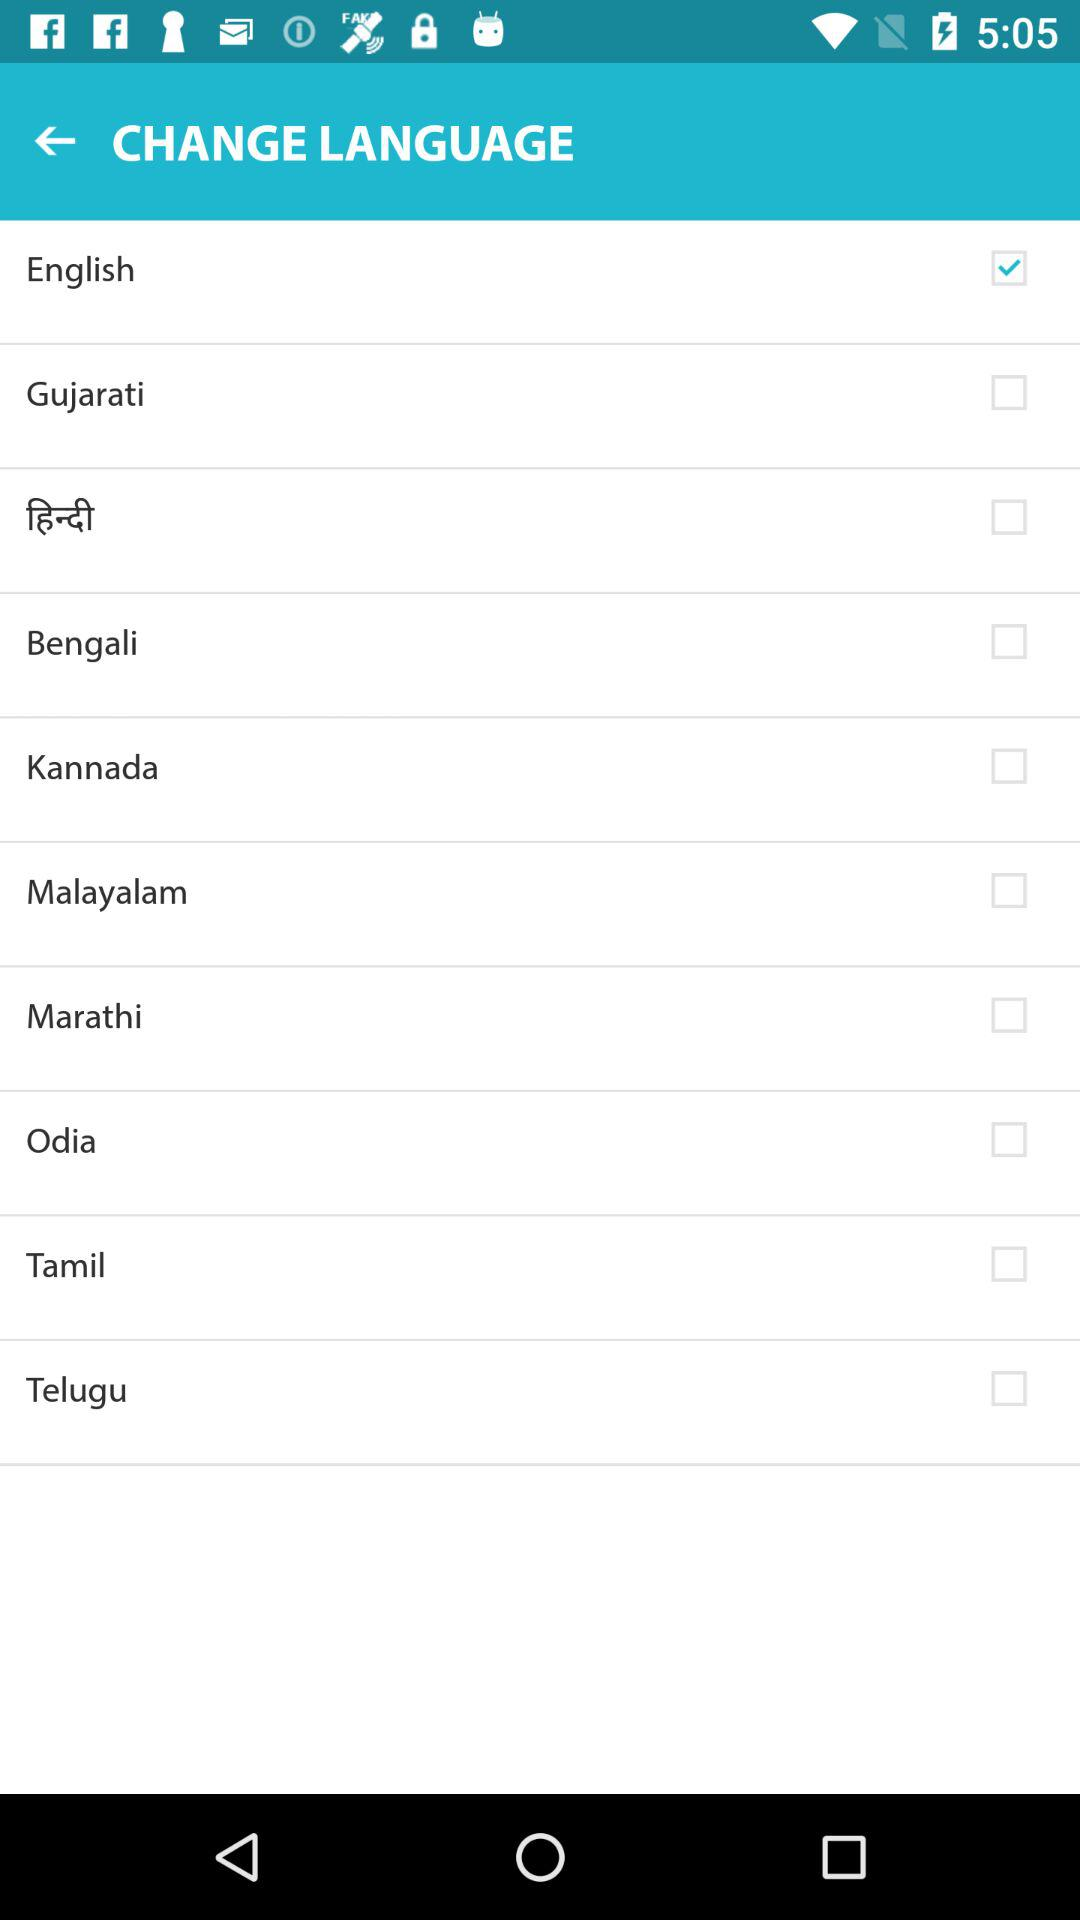What is the status of the "Gujarati" language? The status is "off". 